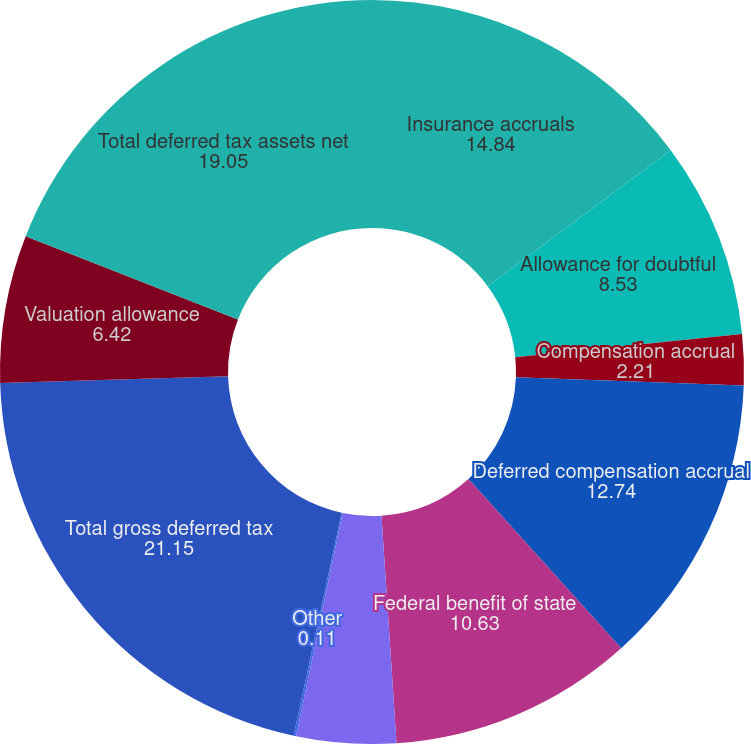Convert chart. <chart><loc_0><loc_0><loc_500><loc_500><pie_chart><fcel>Insurance accruals<fcel>Allowance for doubtful<fcel>Compensation accrual<fcel>Deferred compensation accrual<fcel>Federal benefit of state<fcel>State NOL carry-forward<fcel>Other<fcel>Total gross deferred tax<fcel>Valuation allowance<fcel>Total deferred tax assets net<nl><fcel>14.84%<fcel>8.53%<fcel>2.21%<fcel>12.74%<fcel>10.63%<fcel>4.32%<fcel>0.11%<fcel>21.15%<fcel>6.42%<fcel>19.05%<nl></chart> 